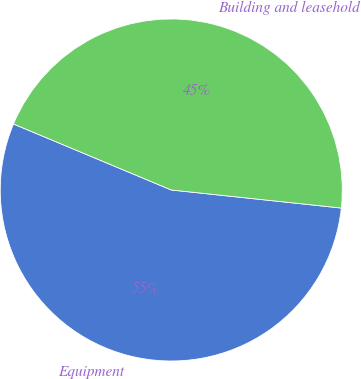Convert chart. <chart><loc_0><loc_0><loc_500><loc_500><pie_chart><fcel>Equipment<fcel>Building and leasehold<nl><fcel>54.62%<fcel>45.38%<nl></chart> 